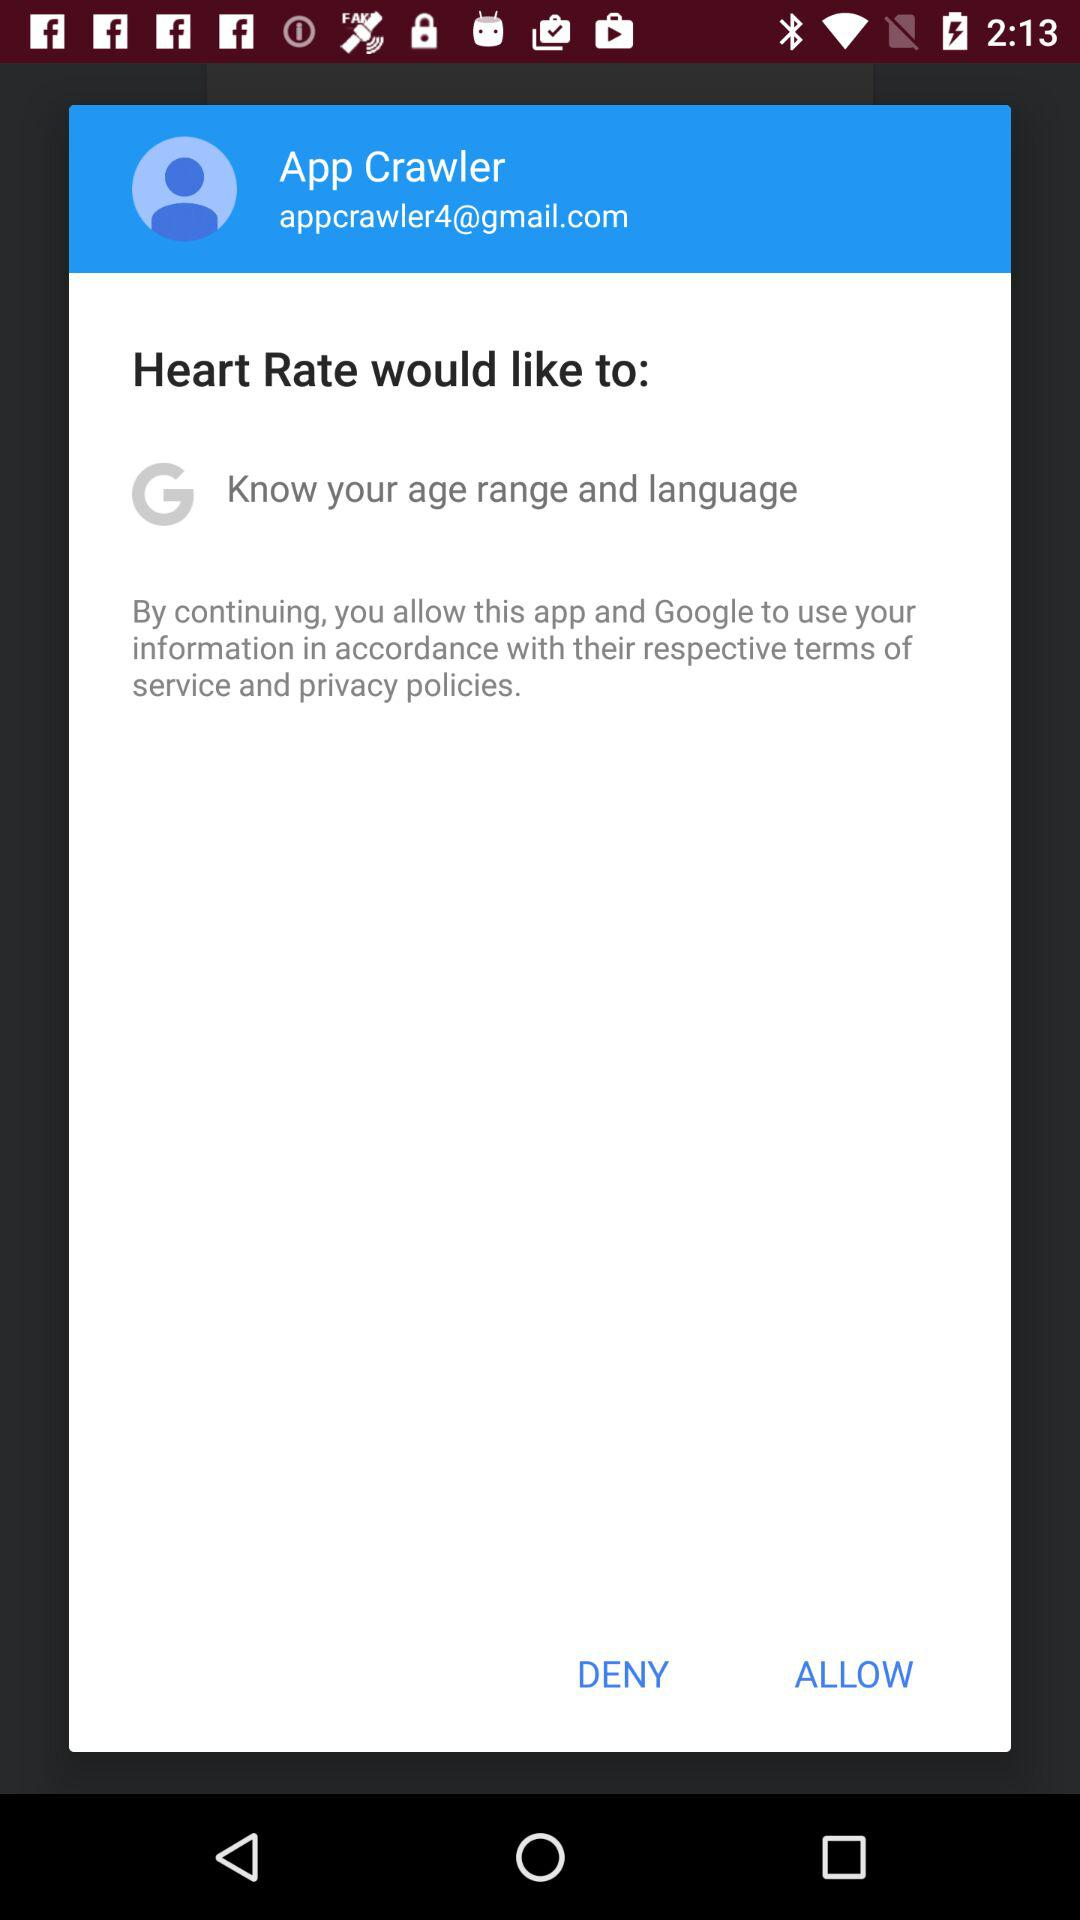What application is asking for permission? The application asking for permission is "Heart Rate". 